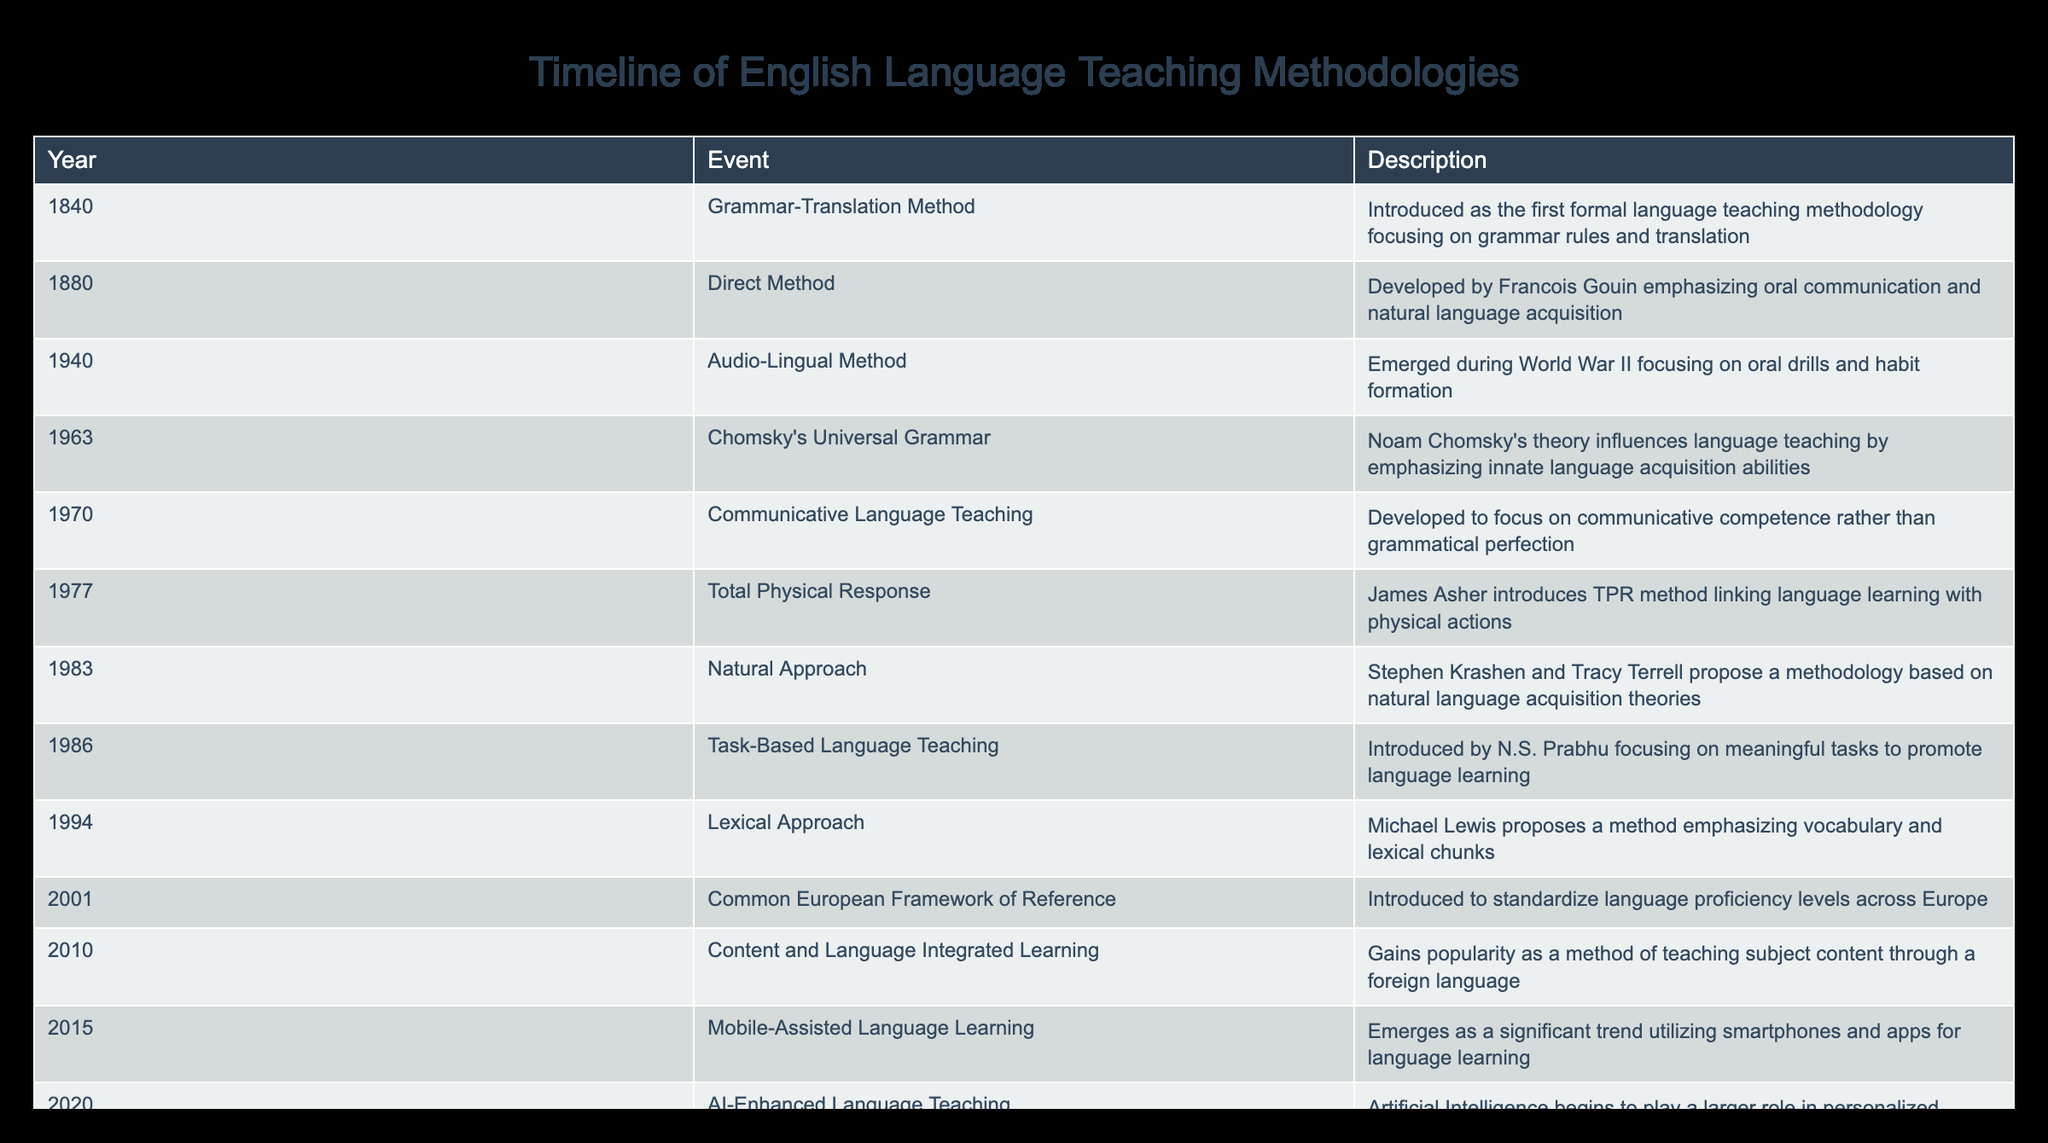What was the first formal language teaching methodology introduced? The first formal language teaching methodology as per the table is the Grammar-Translation Method introduced in 1840.
Answer: Grammar-Translation Method Which methodology emerged during World War II? According to the table, the Audio-Lingual Method emerged during World War II in 1940.
Answer: Audio-Lingual Method How many years passed between the introduction of the Direct Method and the Natural Approach? The Direct Method was introduced in 1880 and the Natural Approach in 1983. The difference in years is 1983 - 1880 = 103 years.
Answer: 103 years Was the Communicative Language Teaching methodology developed before or after 1970? The table shows that Communicative Language Teaching was developed in 1970, which means it was developed in that year itself.
Answer: No (it was developed in 1970) Which methodology emphasizes vocabulary and lexical chunks? Based on the table, the methodology that emphasizes vocabulary and lexical chunks is the Lexical Approach introduced in 1994.
Answer: Lexical Approach What is the last methodology mentioned in the table and what year was it introduced? The last methodology mentioned in the table is AI-Enhanced Language Teaching, which was introduced in 2020.
Answer: AI-Enhanced Language Teaching, 2020 How many methodologies were introduced between 1970 and 1990? The table lists five methodologies introduced during this period: Communicative Language Teaching (1970), Total Physical Response (1977), Natural Approach (1983), Task-Based Language Teaching (1986), and Lexical Approach (1994). Thus, there are five methodologies in total.
Answer: 5 methodologies Did Total Physical Response come before or after Chomsky's Universal Grammar? The table indicates that Chomsky's Universal Grammar was introduced in 1963 and Total Physical Response in 1977, showing that TPR came after Chomsky's theory.
Answer: After What is the average year of introduction for the methodologies listed in the table? We can find the average year by adding all the years together (1840 + 1880 + 1940 + 1963 + 1970 + 1977 + 1983 + 1986 + 1994 + 2001 + 2010 + 2015 + 2020 = 26388) and dividing by the number of methodologies (13). Thus, the average year is 26388 / 13 ≈ 2024. However, as there have not been methodologies introduced in that year, it can be more contextually analyzed to be approximately 2000.
Answer: Approximately 2000 